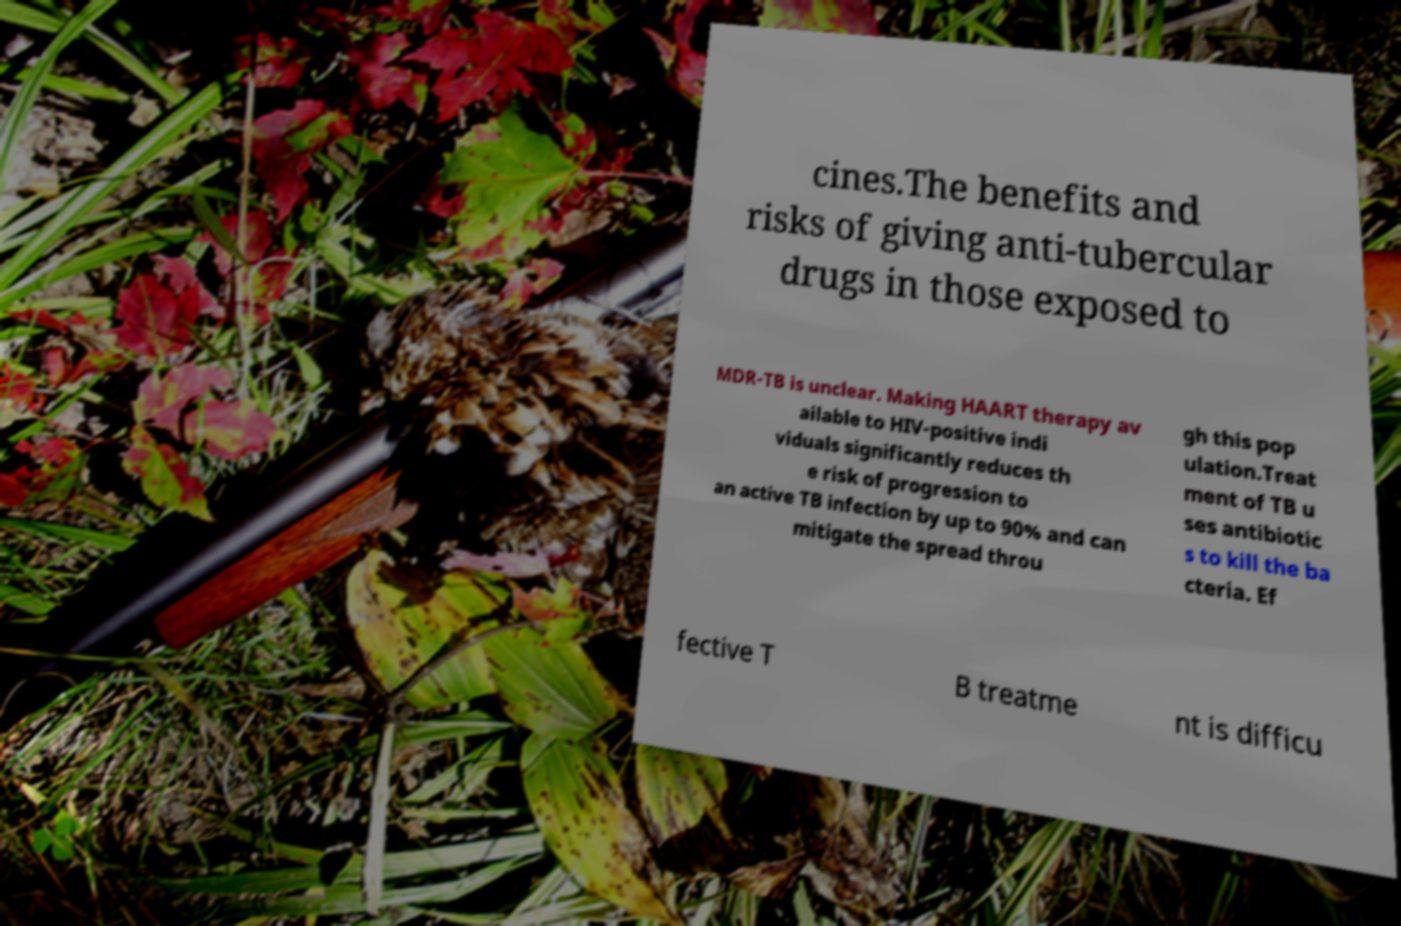For documentation purposes, I need the text within this image transcribed. Could you provide that? cines.The benefits and risks of giving anti-tubercular drugs in those exposed to MDR-TB is unclear. Making HAART therapy av ailable to HIV-positive indi viduals significantly reduces th e risk of progression to an active TB infection by up to 90% and can mitigate the spread throu gh this pop ulation.Treat ment of TB u ses antibiotic s to kill the ba cteria. Ef fective T B treatme nt is difficu 